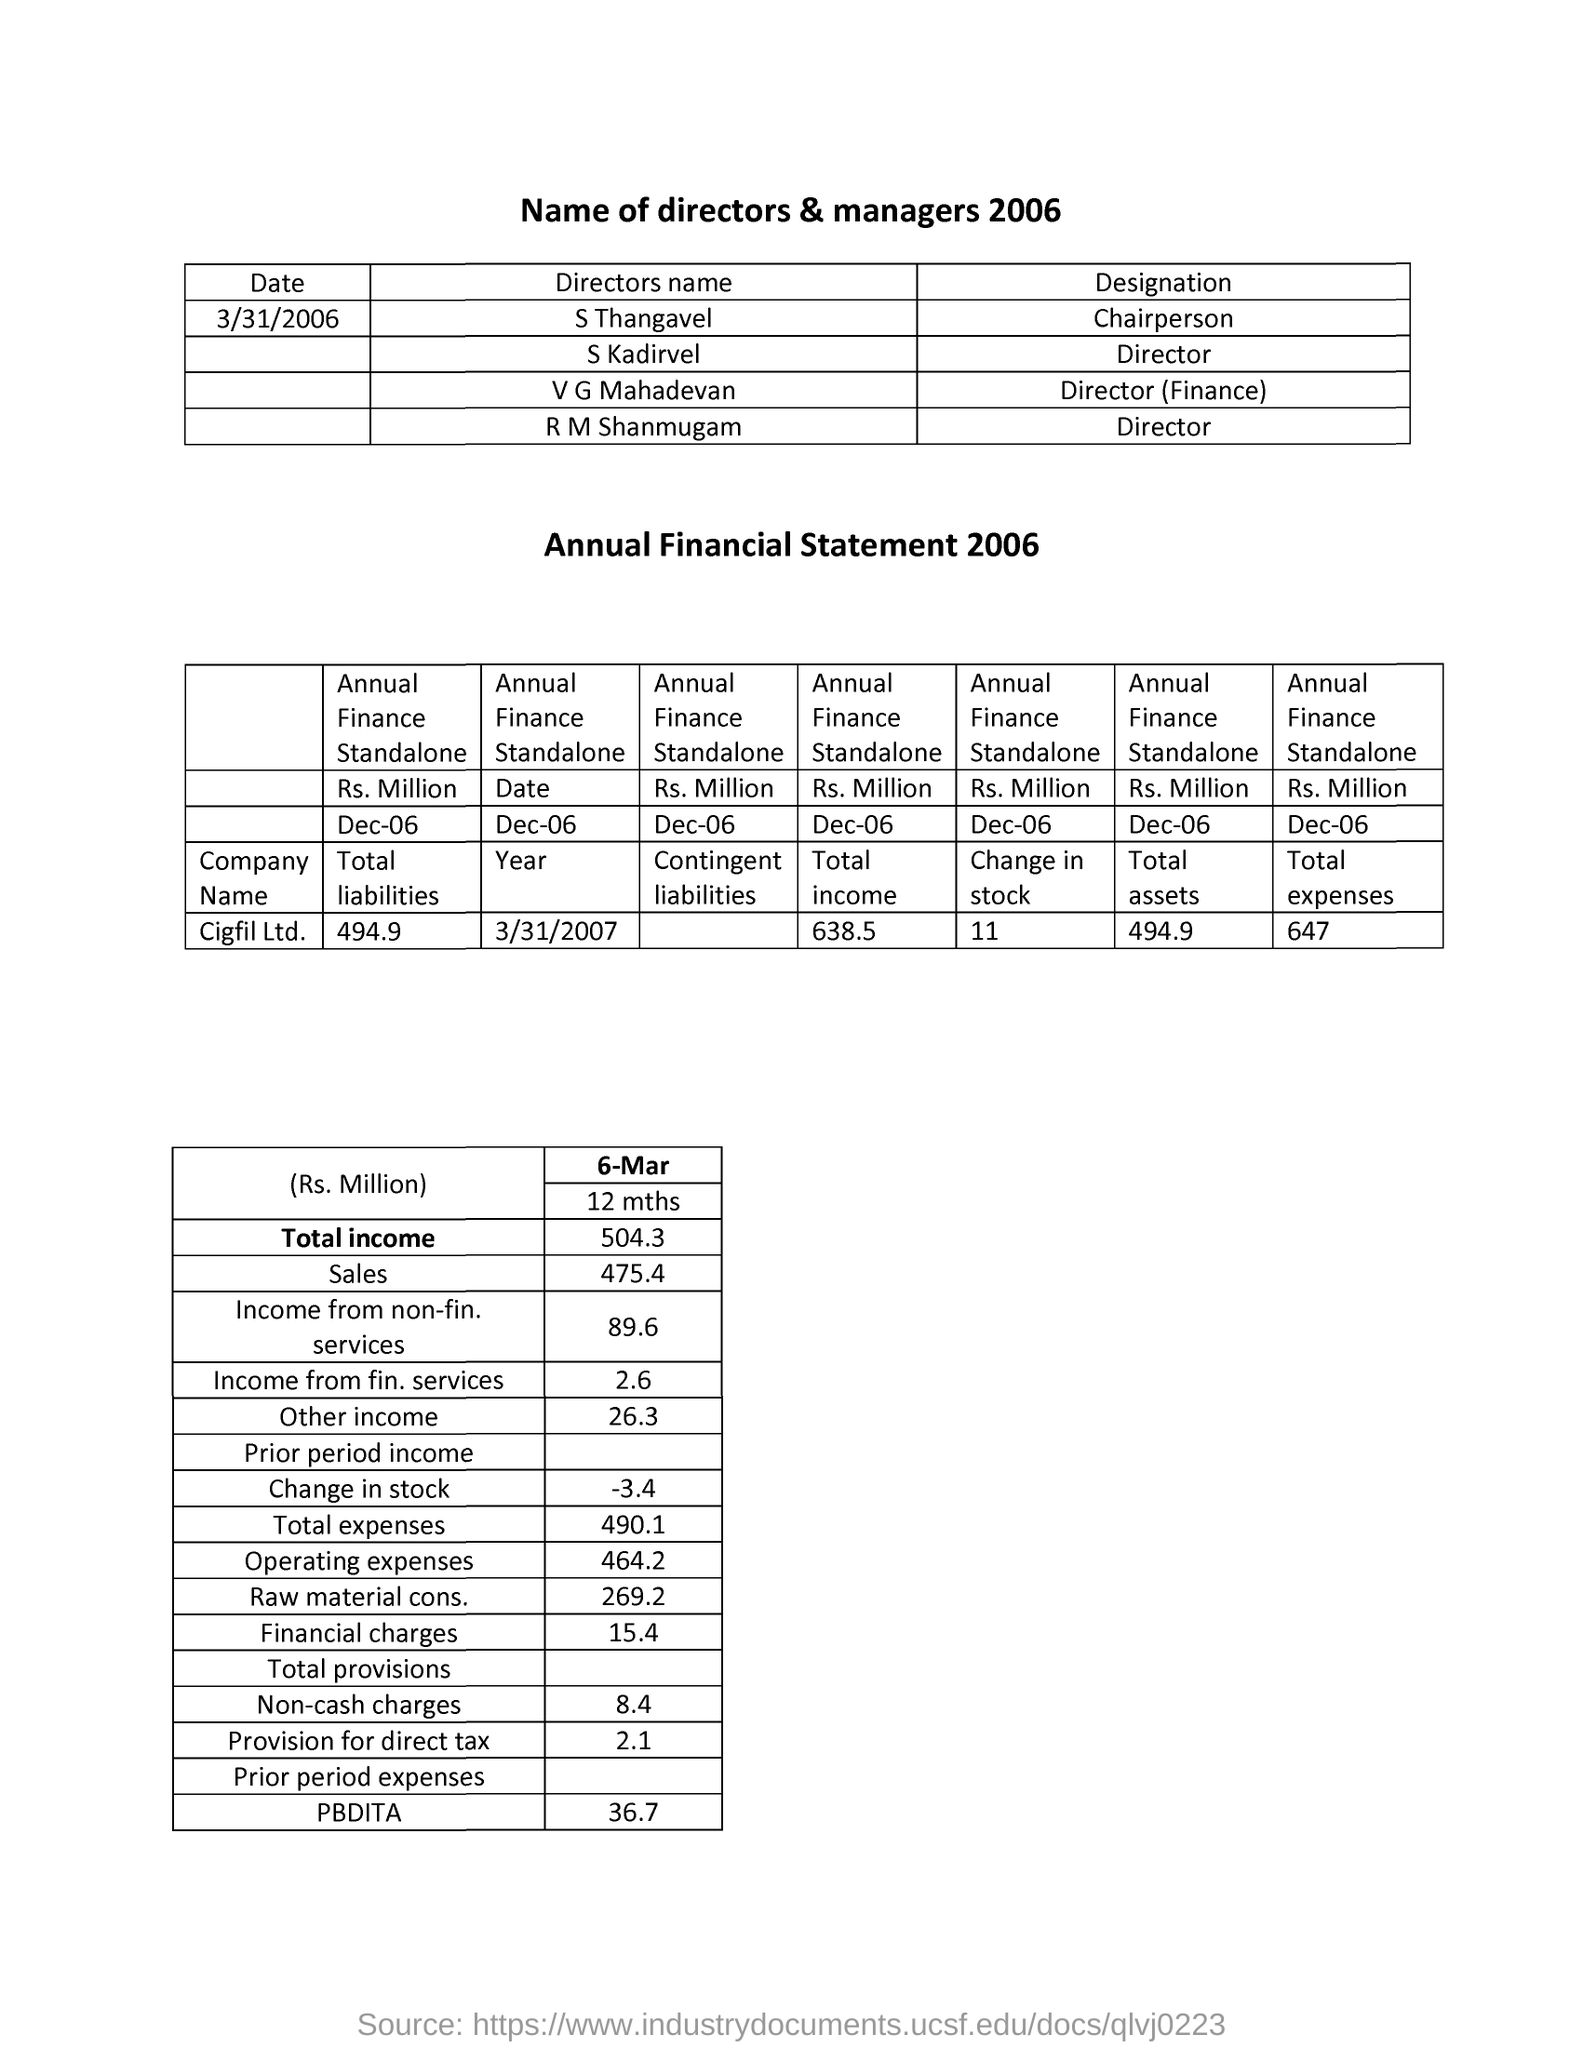What is the Designation of S Thangavel ?
Ensure brevity in your answer.  Chairperson. Who is the Director of Finance ?
Offer a very short reply. V G Mahadevan. What is the Designation of S Kardivel ?
Offer a very short reply. Director. 